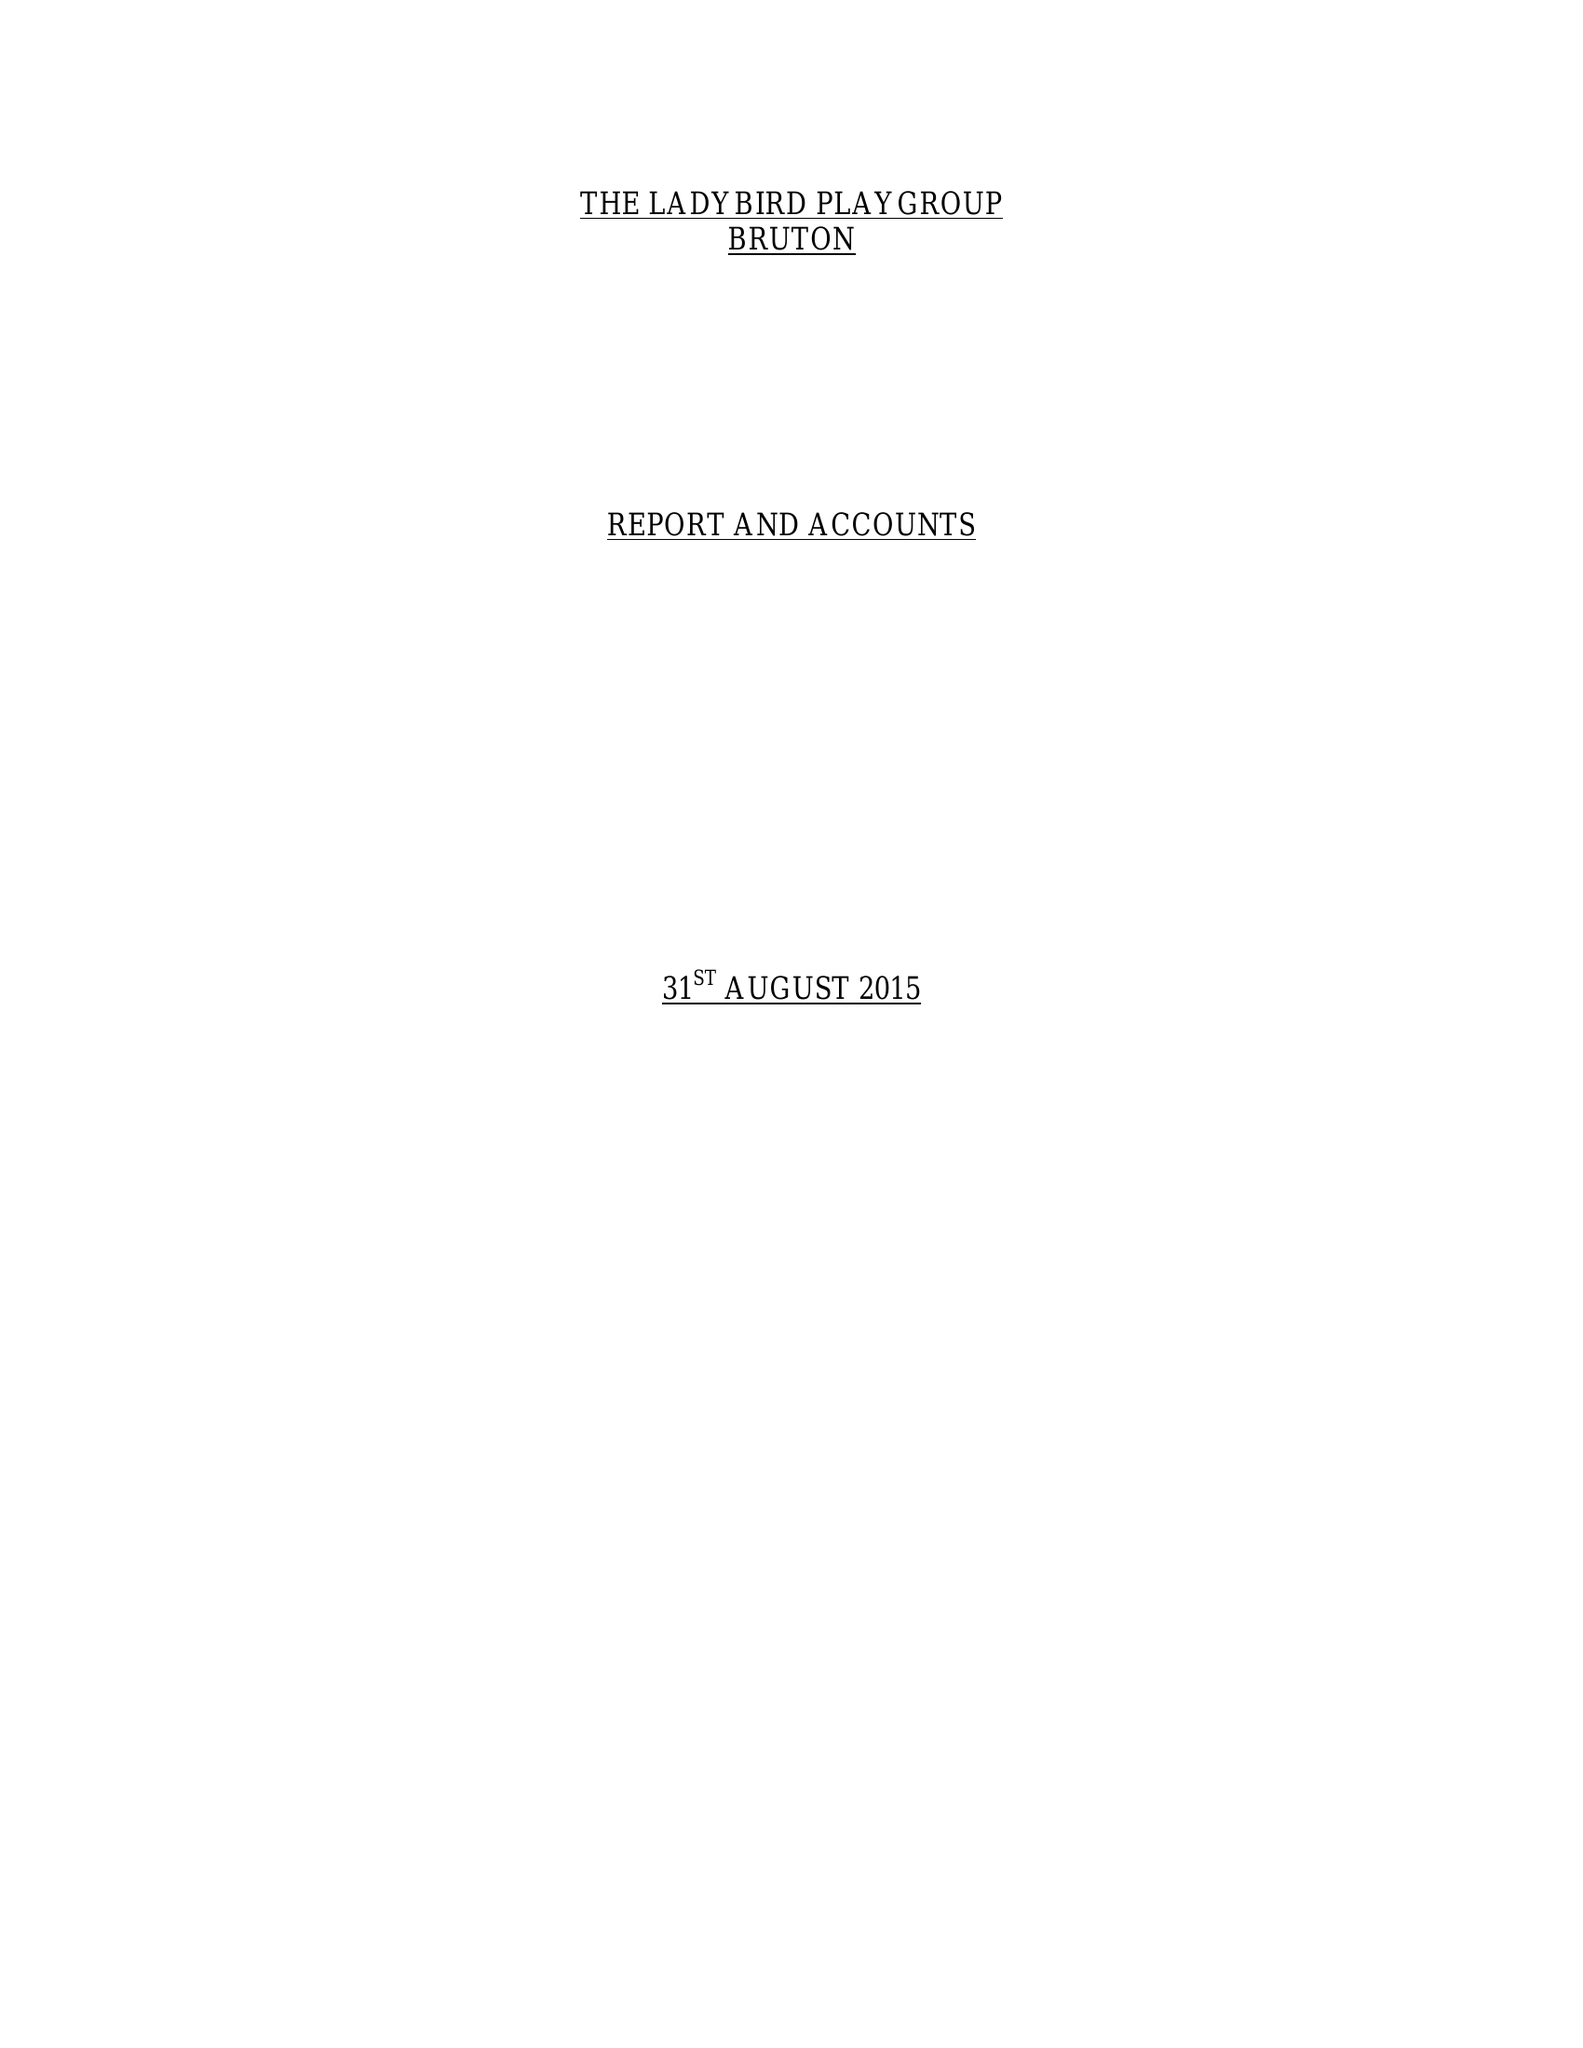What is the value for the spending_annually_in_british_pounds?
Answer the question using a single word or phrase. 76174.00 